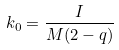Convert formula to latex. <formula><loc_0><loc_0><loc_500><loc_500>k _ { 0 } = \frac { I } { M ( 2 - q ) }</formula> 